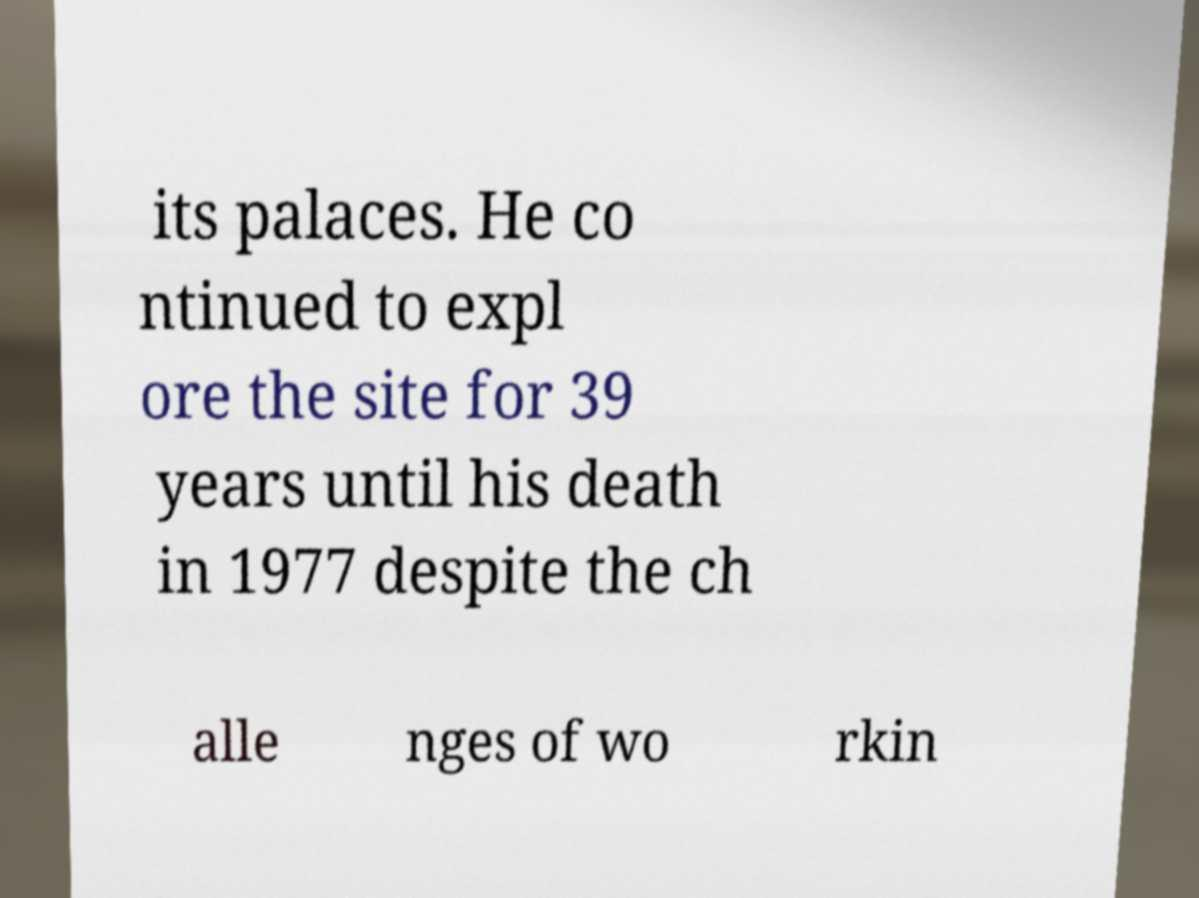Could you extract and type out the text from this image? its palaces. He co ntinued to expl ore the site for 39 years until his death in 1977 despite the ch alle nges of wo rkin 